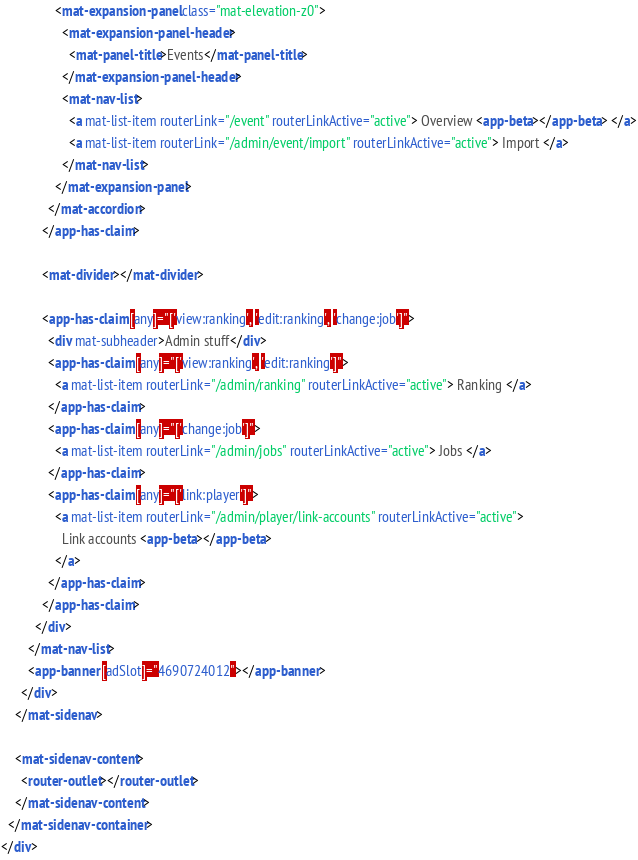<code> <loc_0><loc_0><loc_500><loc_500><_HTML_>                <mat-expansion-panel class="mat-elevation-z0">
                  <mat-expansion-panel-header>
                    <mat-panel-title>Events</mat-panel-title>
                  </mat-expansion-panel-header>
                  <mat-nav-list>
                    <a mat-list-item routerLink="/event" routerLinkActive="active"> Overview <app-beta></app-beta> </a>
                    <a mat-list-item routerLink="/admin/event/import" routerLinkActive="active"> Import </a>
                  </mat-nav-list>
                </mat-expansion-panel>
              </mat-accordion>
            </app-has-claim>

            <mat-divider></mat-divider>

            <app-has-claim [any]="['view:ranking', 'edit:ranking', 'change:job']">
              <div mat-subheader>Admin stuff</div>
              <app-has-claim [any]="['view:ranking', 'edit:ranking']">
                <a mat-list-item routerLink="/admin/ranking" routerLinkActive="active"> Ranking </a>
              </app-has-claim>
              <app-has-claim [any]="['change:job']">
                <a mat-list-item routerLink="/admin/jobs" routerLinkActive="active"> Jobs </a>
              </app-has-claim>
              <app-has-claim [any]="['link:player']">
                <a mat-list-item routerLink="/admin/player/link-accounts" routerLinkActive="active">
                  Link accounts <app-beta></app-beta>
                </a>
              </app-has-claim>
            </app-has-claim>
          </div>
        </mat-nav-list>
        <app-banner [adSlot]="4690724012"></app-banner>
      </div>
    </mat-sidenav>

    <mat-sidenav-content>
      <router-outlet></router-outlet>
    </mat-sidenav-content>
  </mat-sidenav-container>
</div>
</code> 